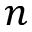<formula> <loc_0><loc_0><loc_500><loc_500>n</formula> 